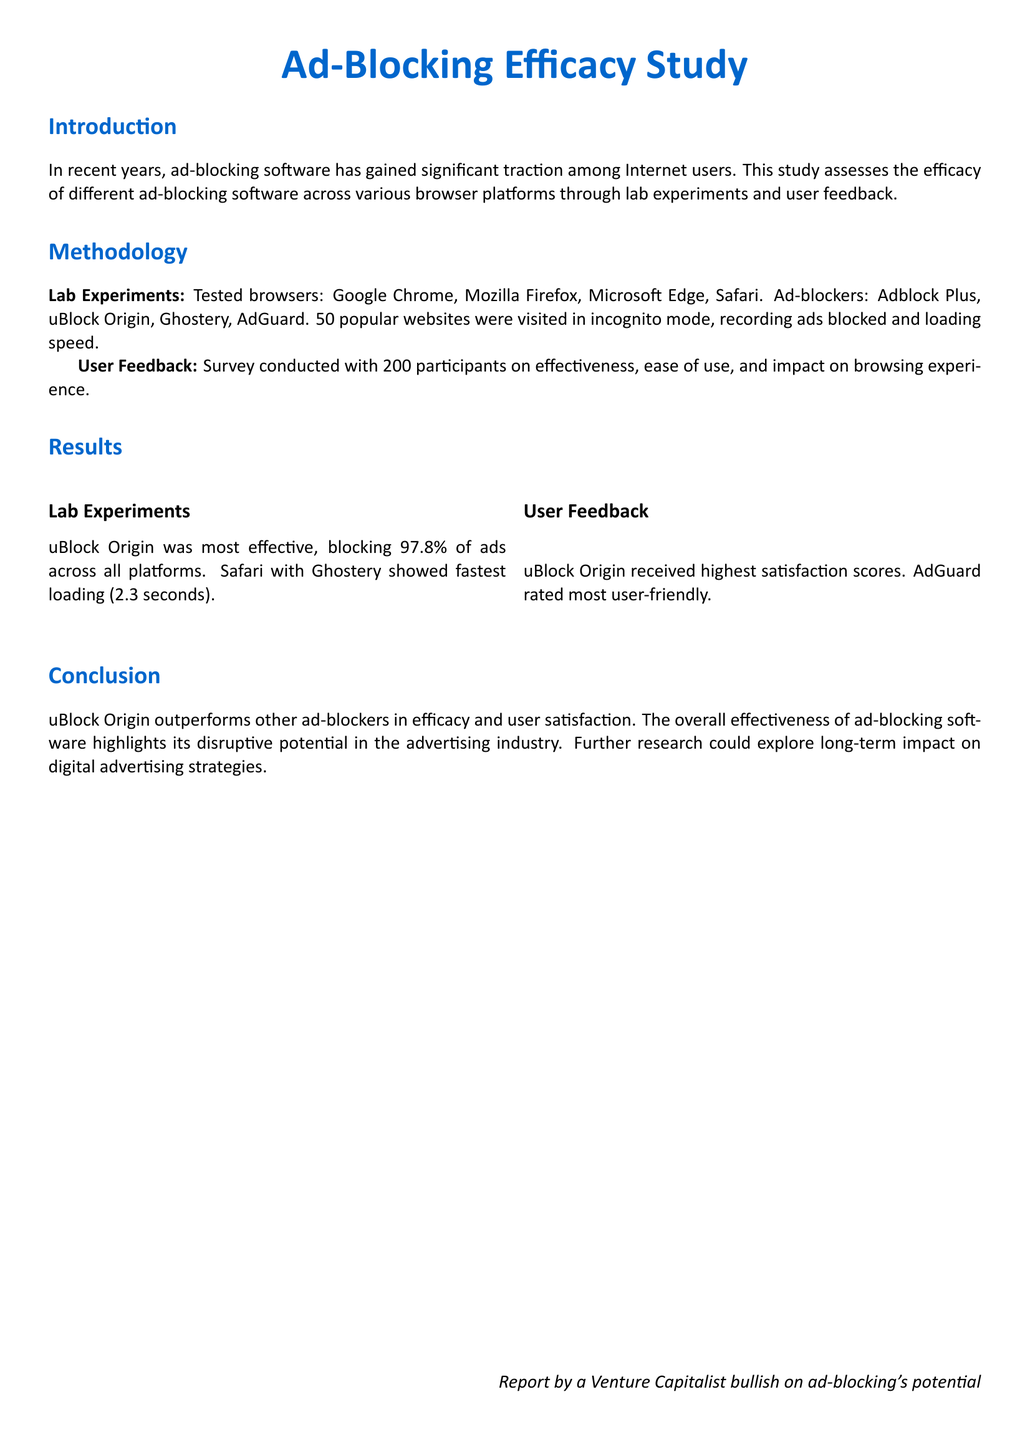What was the most effective ad blocker? The study indicates that uBlock Origin was the most effective, blocking 97.8% of ads across all platforms.
Answer: uBlock Origin Which browser had the fastest loading time with Ghostery? The document states that Safari with Ghostery showed the fastest loading time of 2.3 seconds.
Answer: Safari How many participants were involved in the user feedback survey? The methodology section mentions that 200 participants were surveyed for feedback.
Answer: 200 What is the overall satisfaction score for AdGuard? The user feedback table shows that AdGuard received an overall satisfaction score of 4.6.
Answer: 4.6 Which ad blocker was rated the most user-friendly? According to user feedback, AdGuard was rated the most user-friendly among the ad blockers tested.
Answer: AdGuard What metric received the highest score for uBlock Origin? The effectiveness metric received the highest score for uBlock Origin, which is 4.8.
Answer: 4.8 Which ad blocker blocked the least ads on Chrome? The table indicates Adblock Plus blocked the least ads on Chrome, at 87%.
Answer: Adblock Plus What is the conclusion regarding ad-blocking software? The conclusion emphasizes the overall effectiveness of ad-blocking software and its disruptive potential in the advertising industry.
Answer: Disruptive potential Which section discusses lab experiments conducted? The methodology section details the lab experiments conducted in the study.
Answer: Methodology 